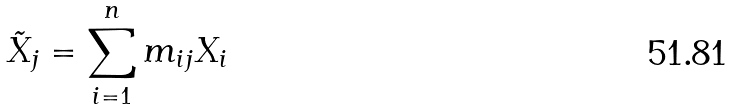Convert formula to latex. <formula><loc_0><loc_0><loc_500><loc_500>\tilde { X } _ { j } = \sum _ { i = 1 } ^ { n } m _ { i j } X _ { i }</formula> 